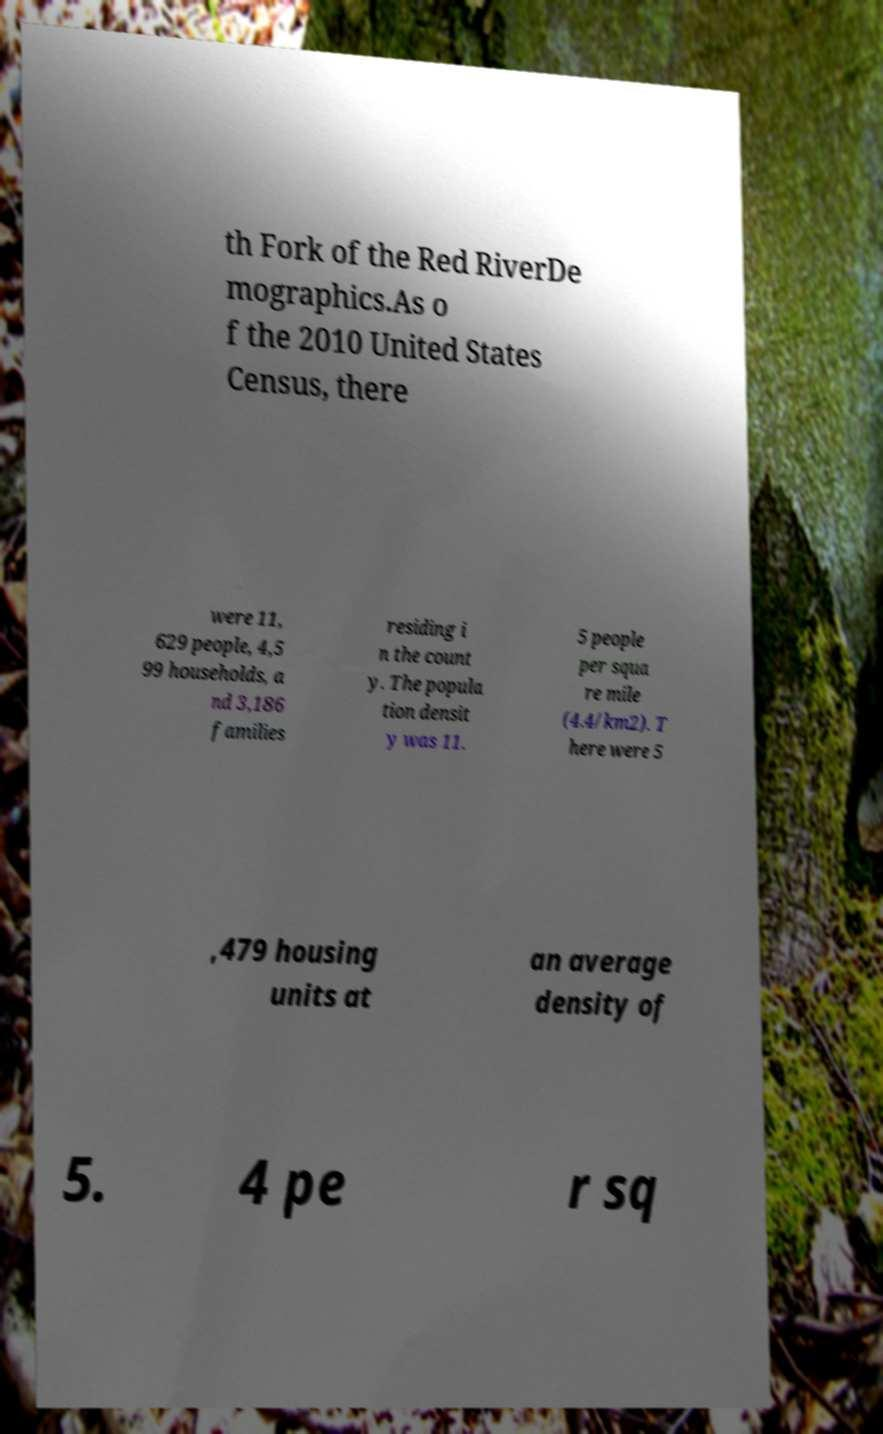Could you assist in decoding the text presented in this image and type it out clearly? th Fork of the Red RiverDe mographics.As o f the 2010 United States Census, there were 11, 629 people, 4,5 99 households, a nd 3,186 families residing i n the count y. The popula tion densit y was 11. 5 people per squa re mile (4.4/km2). T here were 5 ,479 housing units at an average density of 5. 4 pe r sq 